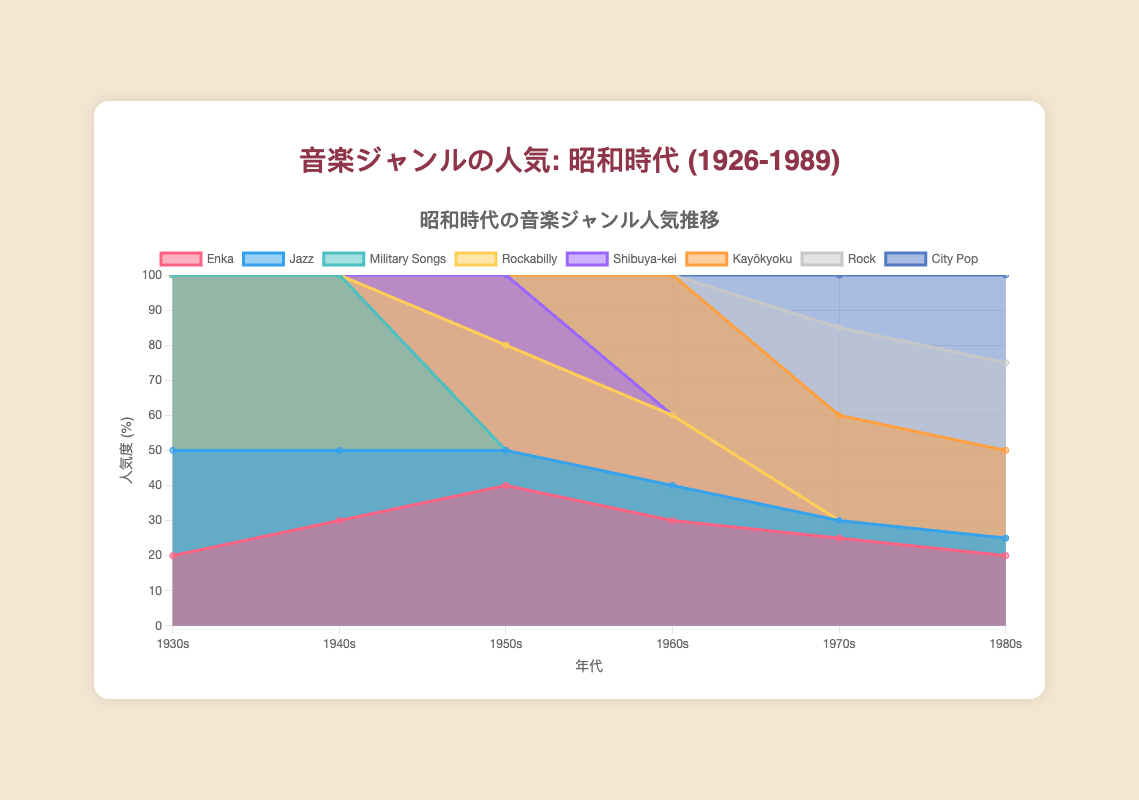How many genres were popular during the 1950s? To answer this, look at the data segment for the 1950s and count the number of different genres listed. There are four genres mentioned: Enka, Jazz, Rockabilly, and Shibuya-kei.
Answer: 4 Which genre had the highest popularity in the 1930s? Check the data for the 1930s and find the genre with the highest percentage. Military Songs has the highest value at 50%.
Answer: Military Songs By how much did the popularity of Enka change from the 1940s to the 1950s? Look at the values of Enka for the 1940s and 1950s. Enka had 30% in the 1940s and 40% in the 1950s. Subtract 30 from 40 to find the change.
Answer: 10% Which decade saw the introduction of the highest number of new music genres? By examining each decade's list of genres, count the new genres introduced. The 1970s introduced Rock and City Pop, while the 1980s introduced no new genres. The 1950s introduced Rockabilly and Shibuya-kei. So, 1950s and 1970s both introduced the same number.
Answer: 1950s, 1970s What trend can be observed for the popularity of Jazz from the 1930s to the 1980s? Look at the data segment for Jazz from the 1930s to the 1980s. It starts at 30% in the 1930s and ends at 5% in the 1980s, showing a general decline.
Answer: Decline Which genre had a consistent popularity of 50% in the 1930s and 1940s but disappeared afterwards? Refer to the data for 1930s and 1940s and identify the genre with 50% both years. The genre is Military Songs, which then drops to 0% in the 1950s and beyond.
Answer: Military Songs Compare the trend in popularity between Kayōkyoku and City Pop in the 1980s. Check the values of both genres in the 1980s. Kayōkyoku has 25% and City Pop also has 25%, indicating they are equally popular in that decade.
Answer: Equally popular What was the combined popularity of Rock and City Pop in the 1980s? Add the popularity percentages of Rock and City Pop for the 1980s. Both have a value of 25%, so the sum is 25 + 25.
Answer: 50% In which decade did Kayōkyoku reach its peak popularity? Look at the percentages for Kayōkyoku across the decades. It has the highest value in the 1960s at 40%.
Answer: 1960s How does the popularity of Rock in the 1970s compare to the 1980s? Compare the values for Rock in the 1970s and 1980s. Both decades have the same value of 25%.
Answer: Equal 